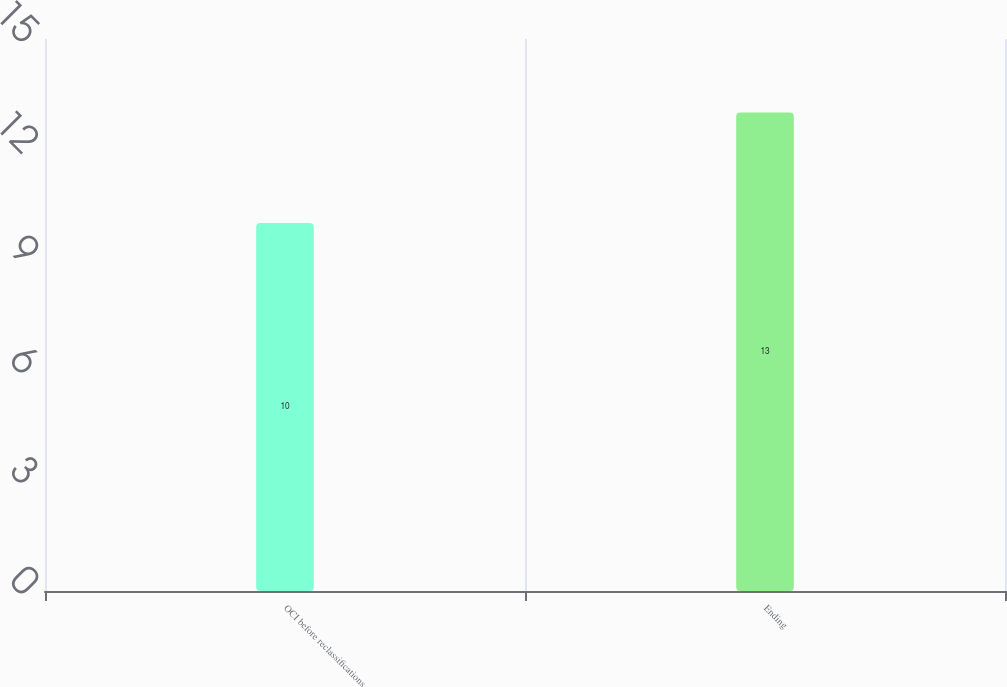Convert chart. <chart><loc_0><loc_0><loc_500><loc_500><bar_chart><fcel>OCI before reclassifications<fcel>Ending<nl><fcel>10<fcel>13<nl></chart> 